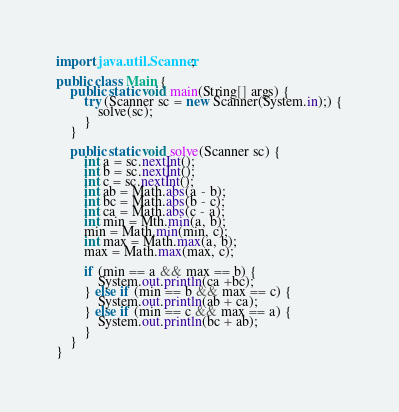<code> <loc_0><loc_0><loc_500><loc_500><_Java_>import java.util.Scanner;

public class Main {
    public static void main(String[] args) {
        try (Scanner sc = new Scanner(System.in);) {
            solve(sc);
        }
    }

    public static void solve(Scanner sc) {
        int a = sc.nextInt();
        int b = sc.nextInt();
        int c = sc.nextInt();
        int ab = Math.abs(a - b);
        int bc = Math.abs(b - c);
        int ca = Math.abs(c - a);
        int min = Mth.min(a, b);
        min = Math.min(min, c);
        int max = Math.max(a, b);
        max = Math.max(max, c);

        if (min == a && max == b) {
            System.out.println(ca +bc);
        } else if (min == b && max == c) {
            System.out.println(ab + ca);
        } else if (min == c && max == a) {
            System.out.println(bc + ab);
        }
    }
}</code> 